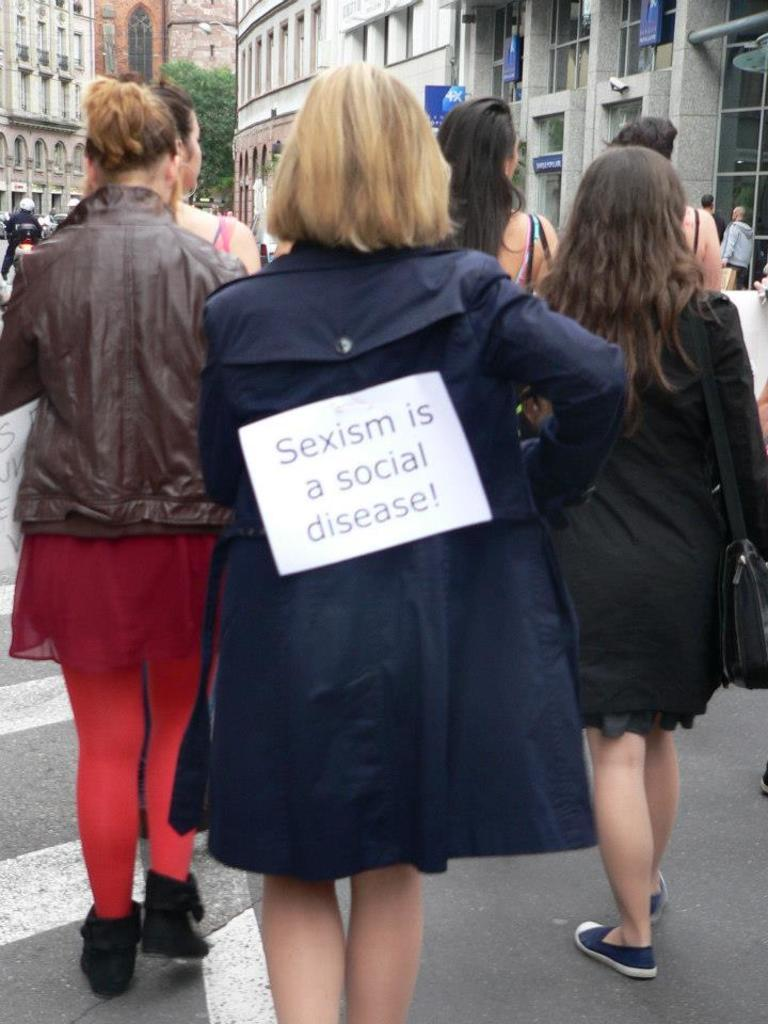How many people can be seen in the image? There are many people in the image. What are some of the people doing in the image? Some people are carrying objects in the image. What can be seen on the board in the image? There is text on a board in the image. What type of structures are visible in the image? There are buildings in the image. What type of vegetation is present in the image? There is a tree in the image. What type of fear can be seen on the faces of the people in the image? There is no indication of fear on the faces of the people in the image. Is it raining in the image? There is no mention of rain in the image, and no evidence of rain can be seen. 